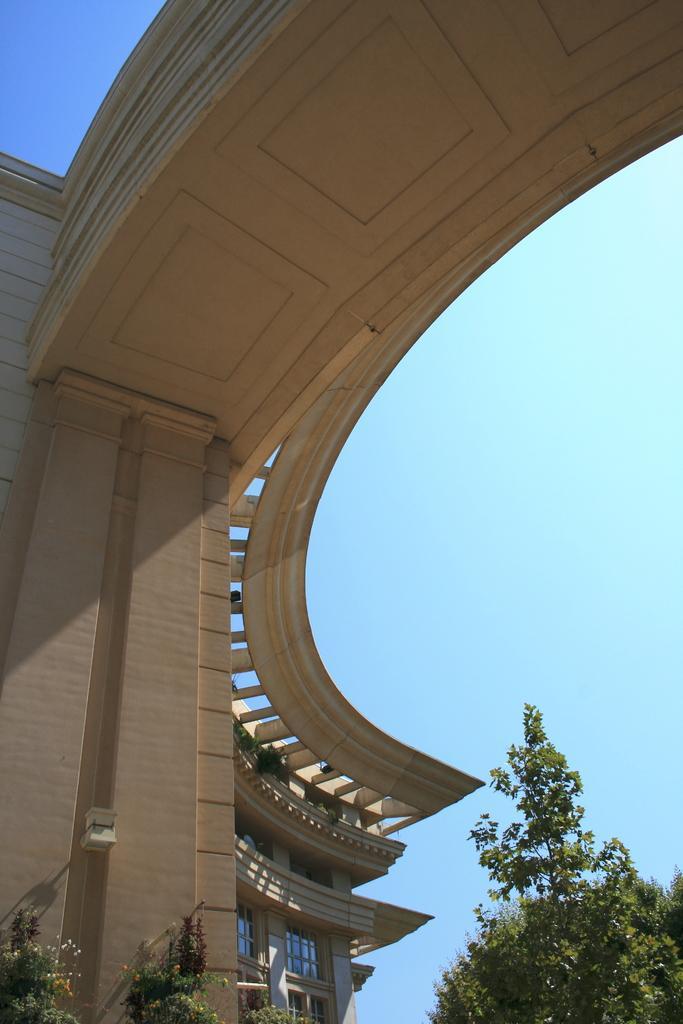Please provide a concise description of this image. This is an outside view. On the left side there is a building. At the bottom there are trees. At the top of the image I can see the sky. 